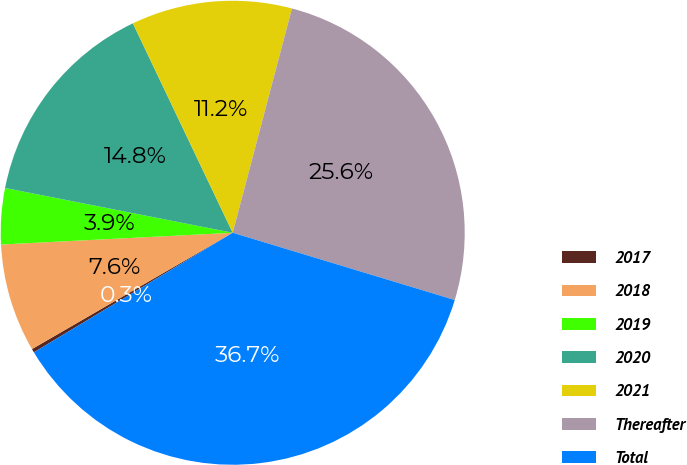Convert chart to OTSL. <chart><loc_0><loc_0><loc_500><loc_500><pie_chart><fcel>2017<fcel>2018<fcel>2019<fcel>2020<fcel>2021<fcel>Thereafter<fcel>Total<nl><fcel>0.26%<fcel>7.55%<fcel>3.9%<fcel>14.83%<fcel>11.19%<fcel>25.57%<fcel>36.7%<nl></chart> 